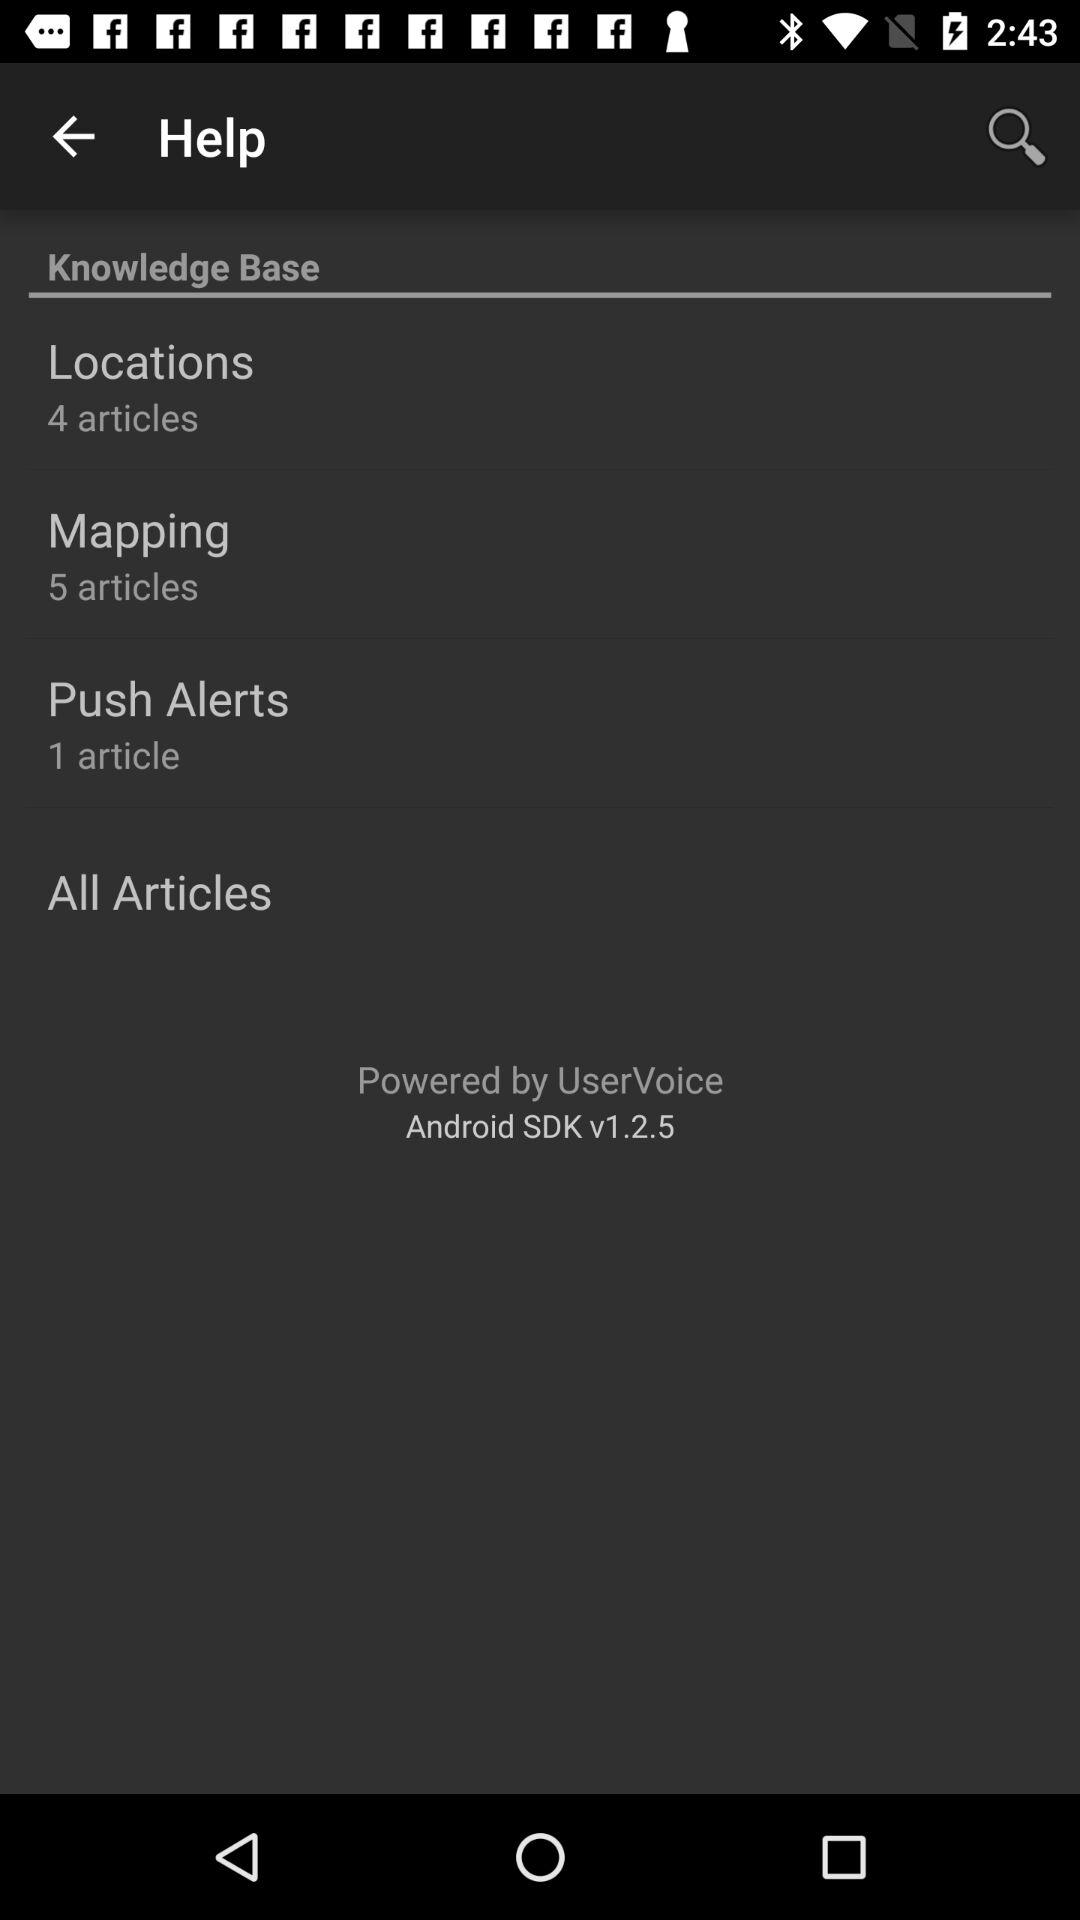What is the total number of articles in "Mapping"? The total number of articles is 5. 